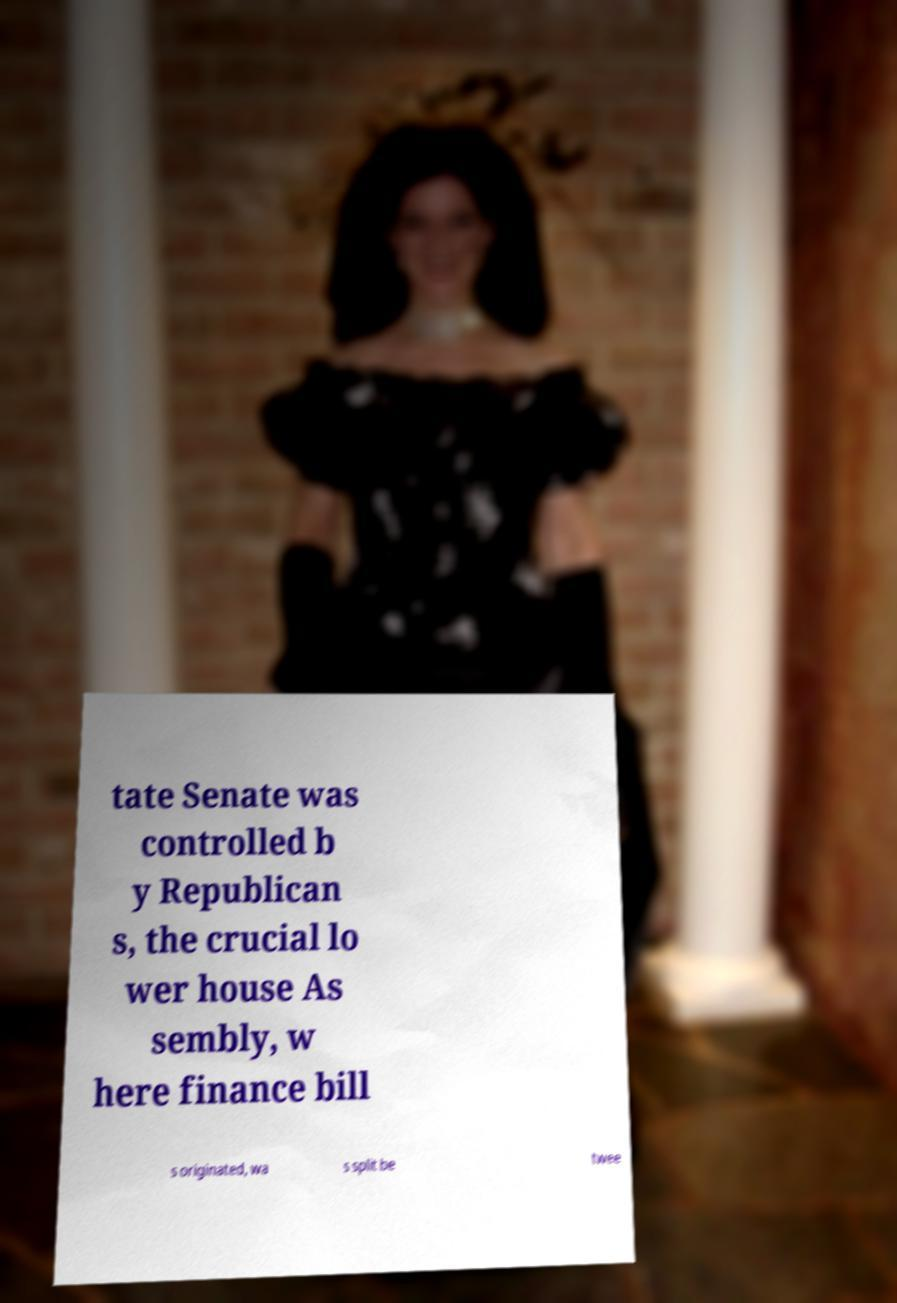Could you extract and type out the text from this image? tate Senate was controlled b y Republican s, the crucial lo wer house As sembly, w here finance bill s originated, wa s split be twee 